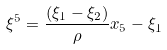<formula> <loc_0><loc_0><loc_500><loc_500>\xi ^ { 5 } = \frac { ( \xi _ { 1 } - \xi _ { 2 } ) } { \rho } x _ { 5 } - \xi _ { 1 }</formula> 